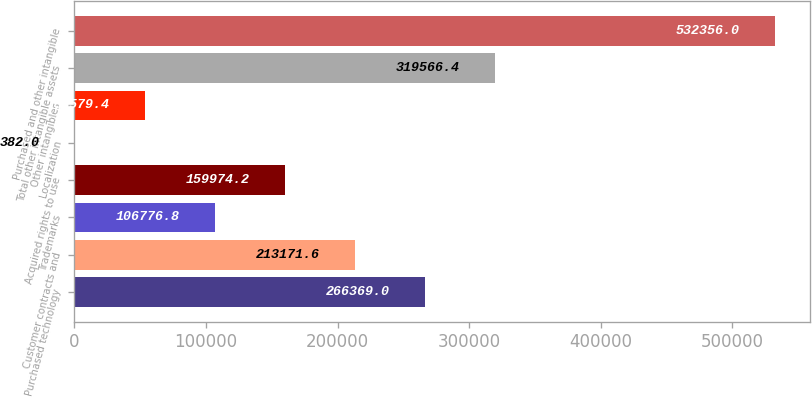Convert chart to OTSL. <chart><loc_0><loc_0><loc_500><loc_500><bar_chart><fcel>Purchased technology<fcel>Customer contracts and<fcel>Trademarks<fcel>Acquired rights to use<fcel>Localization<fcel>Other intangibles<fcel>Total other intangible assets<fcel>Purchased and other intangible<nl><fcel>266369<fcel>213172<fcel>106777<fcel>159974<fcel>382<fcel>53579.4<fcel>319566<fcel>532356<nl></chart> 